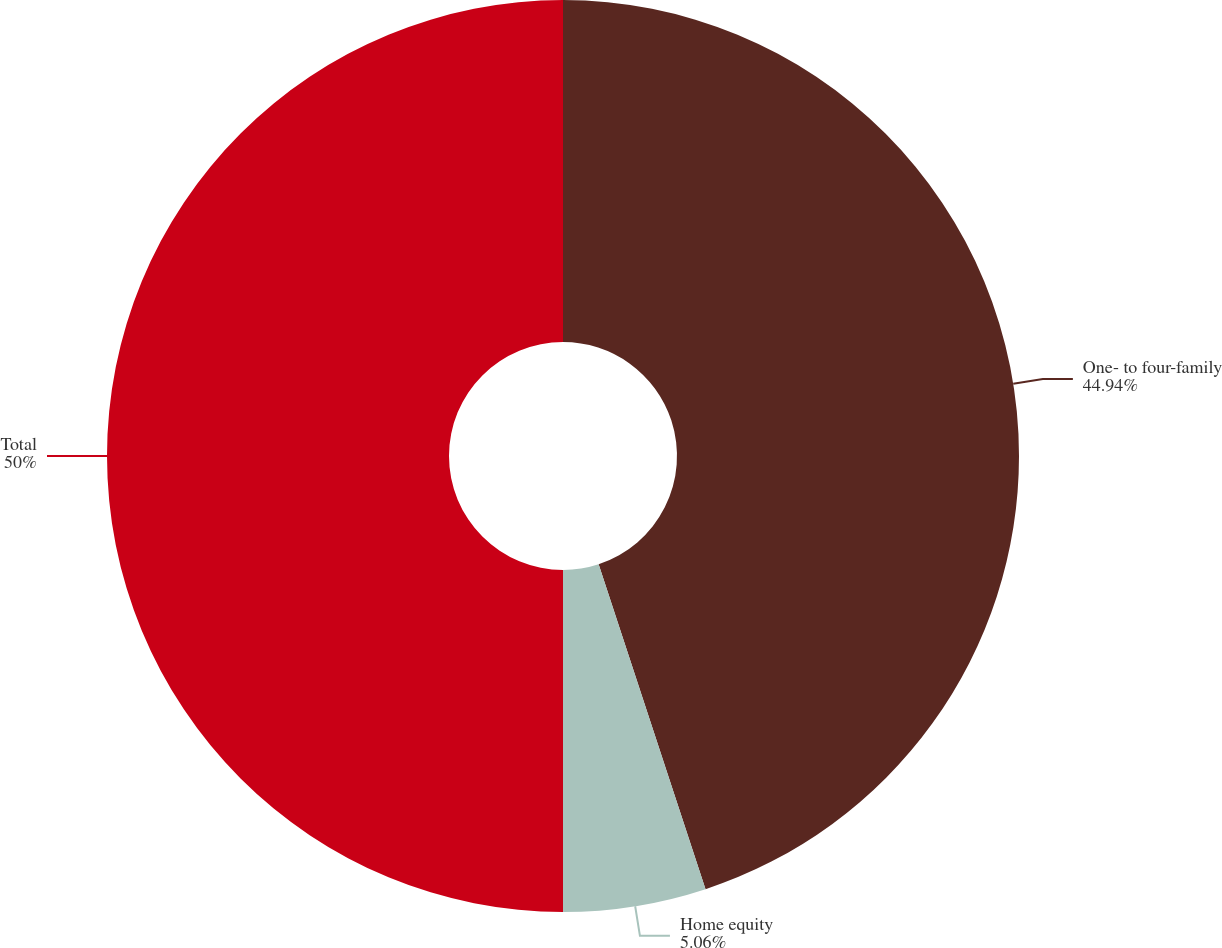Convert chart to OTSL. <chart><loc_0><loc_0><loc_500><loc_500><pie_chart><fcel>One- to four-family<fcel>Home equity<fcel>Total<nl><fcel>44.94%<fcel>5.06%<fcel>50.0%<nl></chart> 